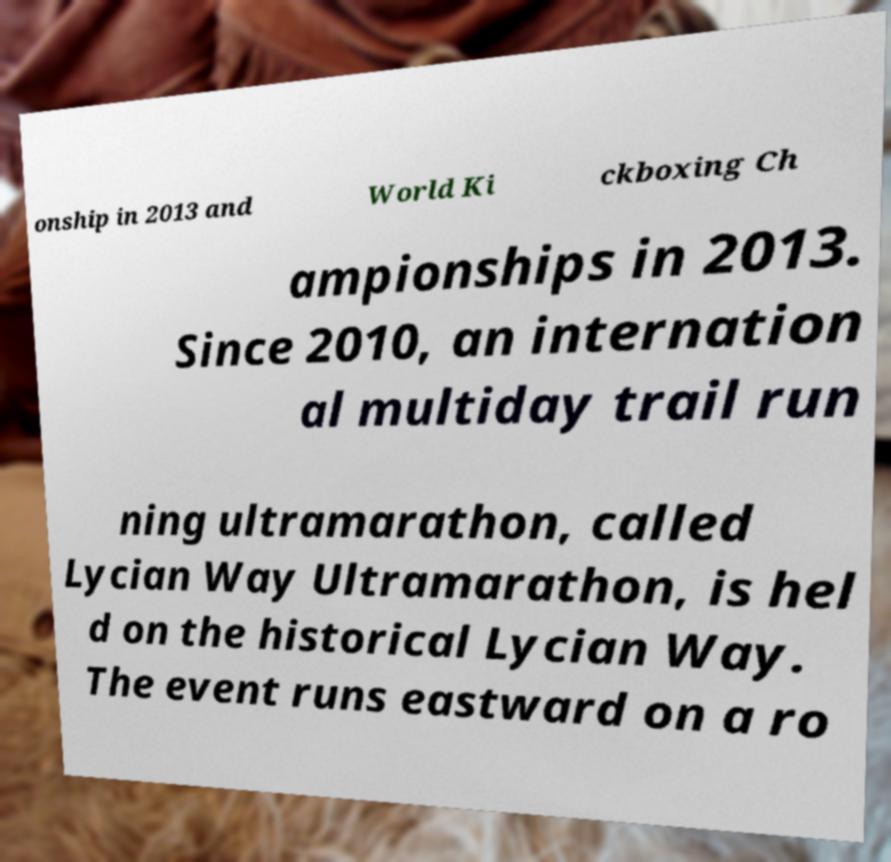Could you extract and type out the text from this image? onship in 2013 and World Ki ckboxing Ch ampionships in 2013. Since 2010, an internation al multiday trail run ning ultramarathon, called Lycian Way Ultramarathon, is hel d on the historical Lycian Way. The event runs eastward on a ro 